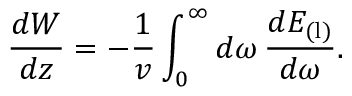<formula> <loc_0><loc_0><loc_500><loc_500>\frac { d W } { d z } = - \frac { 1 } { v } \int _ { 0 } ^ { \infty } d \omega \, \frac { d E _ { ( l ) } } { d \omega } .</formula> 